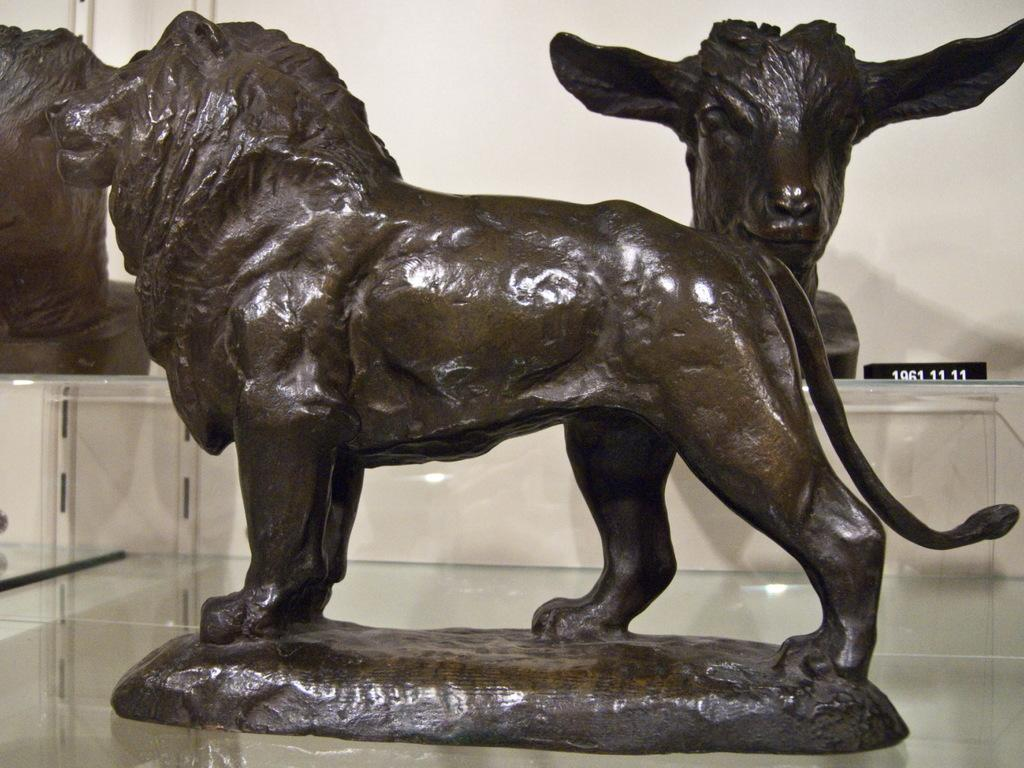What type of statue is in the image? There is a statue of a lion in the image. Where is the statue of the lion located? The statue of the lion is on a platform. What can be seen in the background of the image? There is a wall, statues, and other objects in the background of the image. What type of arch can be seen in the image? There is no arch present in the image. Are the lions in the image fighting with each other? The image only shows a statue of a lion, and there is no indication of any fighting. 